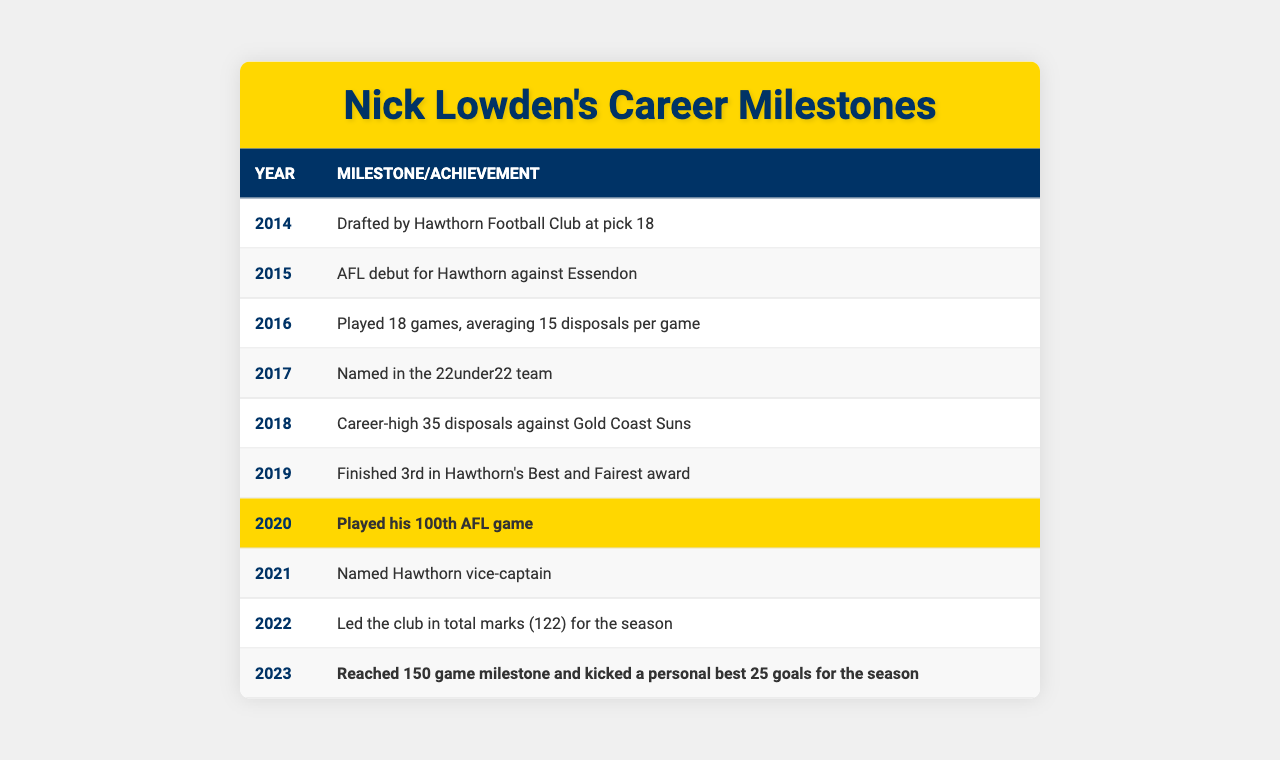What year did Nick Lowden make his AFL debut? The table shows that Nick Lowden made his debut in 2015.
Answer: 2015 What milestone is highlighted in 2020? In 2020, Nick Lowden played his 100th AFL game, which is indicated as a highlight in the table.
Answer: Played his 100th AFL game How many games did Nick Lowden play in 2016? The table specifies that Nick Lowden played 18 games in 2016.
Answer: 18 games What is the career-high number of disposals Nick Lowden achieved, and against which team? The table states that he had a career-high of 35 disposals against the Gold Coast Suns in 2018.
Answer: 35 disposals against Gold Coast Suns In which year was Nick Lowden named Hawthorn vice-captain? According to the table, Nick Lowden was named vice-captain in 2021.
Answer: 2021 How many total marks did he lead the club with in 2022? The table indicates that he led the club with 122 total marks for the season in 2022.
Answer: 122 total marks Did Nick Lowden finish in Hawthorn's Best and Fairest award in 2019? Yes, the table shows that he finished 3rd in the Best and Fairest award in 2019.
Answer: Yes How many goals did Nick Lowden kick in the 2023 season? The table reveals that he kicked a personal best of 25 goals in the 2023 season.
Answer: 25 goals Which year represents the highest personal achievement for disposals? The table shows that 2018 represents the highest achievement for disposals with 35 against Gold Coast Suns.
Answer: 2018 What is the difference in the total number of games played between 2016 and 2020? In 2016, he played 18 games, and by 2020, he had played 100 games; the difference is 100 - 18 = 82 games.
Answer: 82 games In terms of development, how did Nick Lowden progress from being drafted to reaching a leadership position? He was drafted in 2014, made his debut in 2015, had various achievements including playing 100 games by 2020, and was appointed vice-captain in 2021. This indicates consistent growth in performance and recognition.
Answer: From drafted to vice-captain 